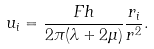Convert formula to latex. <formula><loc_0><loc_0><loc_500><loc_500>u _ { i } = \frac { F h } { 2 \pi ( \lambda + 2 \mu ) } \frac { r _ { i } } { r ^ { 2 } } .</formula> 